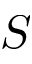<formula> <loc_0><loc_0><loc_500><loc_500>S</formula> 